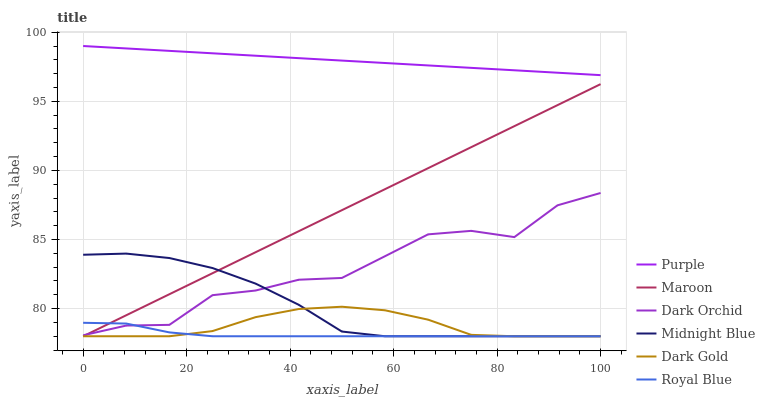Does Royal Blue have the minimum area under the curve?
Answer yes or no. Yes. Does Purple have the maximum area under the curve?
Answer yes or no. Yes. Does Dark Gold have the minimum area under the curve?
Answer yes or no. No. Does Dark Gold have the maximum area under the curve?
Answer yes or no. No. Is Purple the smoothest?
Answer yes or no. Yes. Is Dark Orchid the roughest?
Answer yes or no. Yes. Is Dark Gold the smoothest?
Answer yes or no. No. Is Dark Gold the roughest?
Answer yes or no. No. Does Midnight Blue have the lowest value?
Answer yes or no. Yes. Does Purple have the lowest value?
Answer yes or no. No. Does Purple have the highest value?
Answer yes or no. Yes. Does Dark Gold have the highest value?
Answer yes or no. No. Is Maroon less than Purple?
Answer yes or no. Yes. Is Purple greater than Maroon?
Answer yes or no. Yes. Does Royal Blue intersect Maroon?
Answer yes or no. Yes. Is Royal Blue less than Maroon?
Answer yes or no. No. Is Royal Blue greater than Maroon?
Answer yes or no. No. Does Maroon intersect Purple?
Answer yes or no. No. 